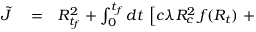<formula> <loc_0><loc_0><loc_500><loc_500>\begin{array} { r l r } { \tilde { J } } & = } & { R _ { t _ { f } } ^ { 2 } + \int _ { 0 } ^ { t _ { f } } d t \, \left [ c \lambda R _ { c } ^ { 2 } \, f ( R _ { t } ) + } \end{array}</formula> 